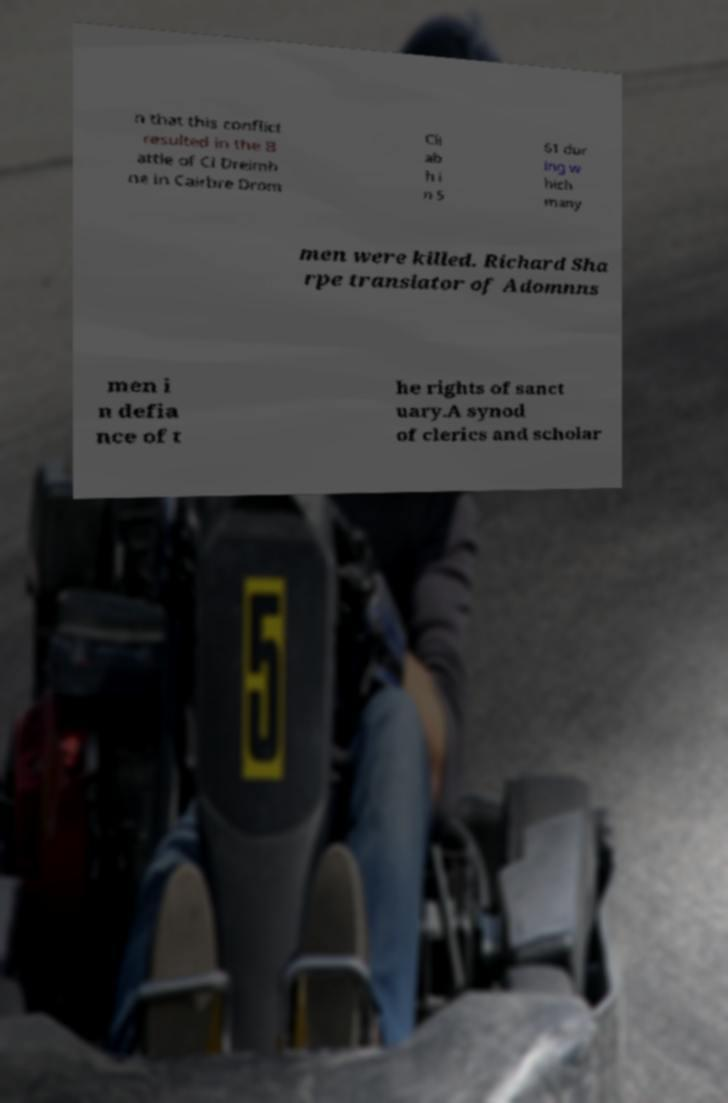Please identify and transcribe the text found in this image. n that this conflict resulted in the B attle of Cl Dreimh ne in Cairbre Drom Cli ab h i n 5 61 dur ing w hich many men were killed. Richard Sha rpe translator of Adomnns men i n defia nce of t he rights of sanct uary.A synod of clerics and scholar 